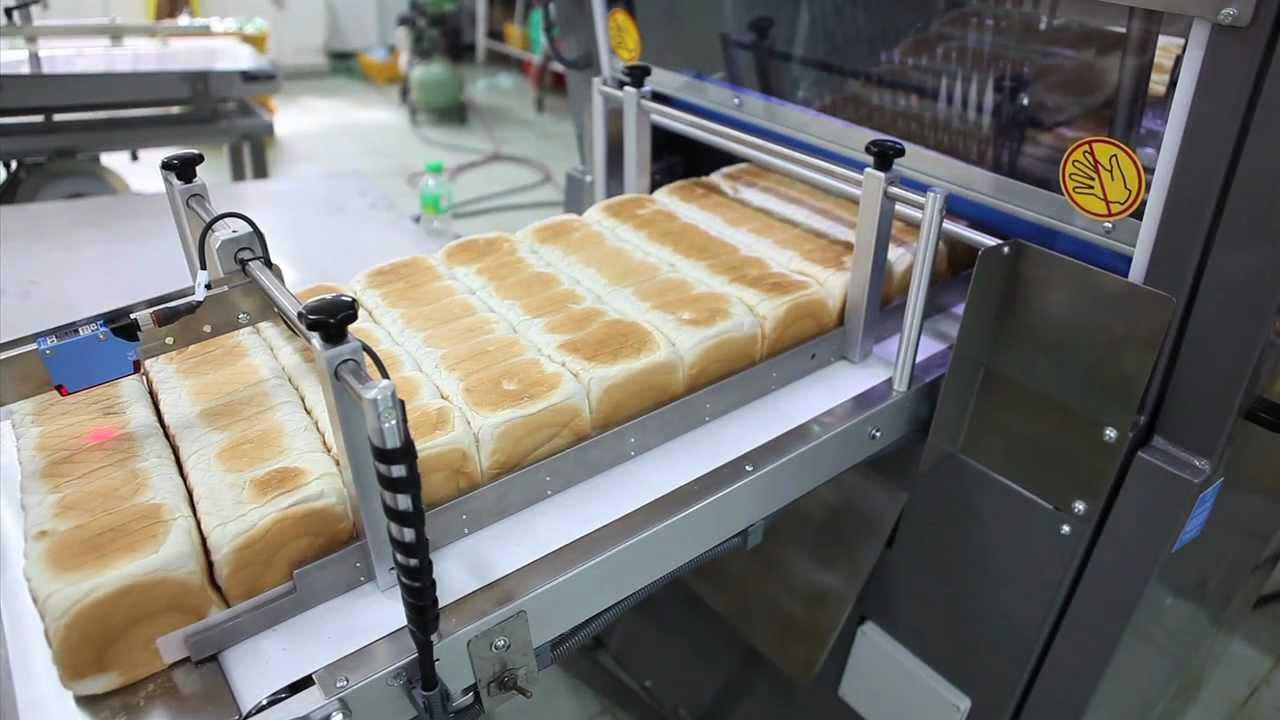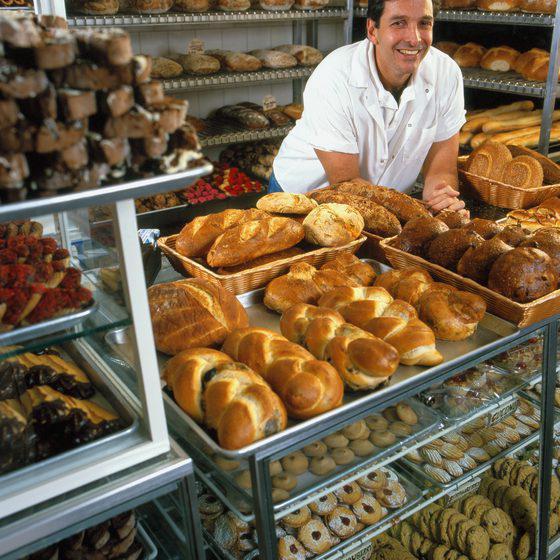The first image is the image on the left, the second image is the image on the right. For the images displayed, is the sentence "The right image shows a smiling man in a white shirt bending forward by racks of bread." factually correct? Answer yes or no. Yes. The first image is the image on the left, the second image is the image on the right. Given the left and right images, does the statement "A baker in a white shirt and hat works in the kitchen in one of the images." hold true? Answer yes or no. No. 